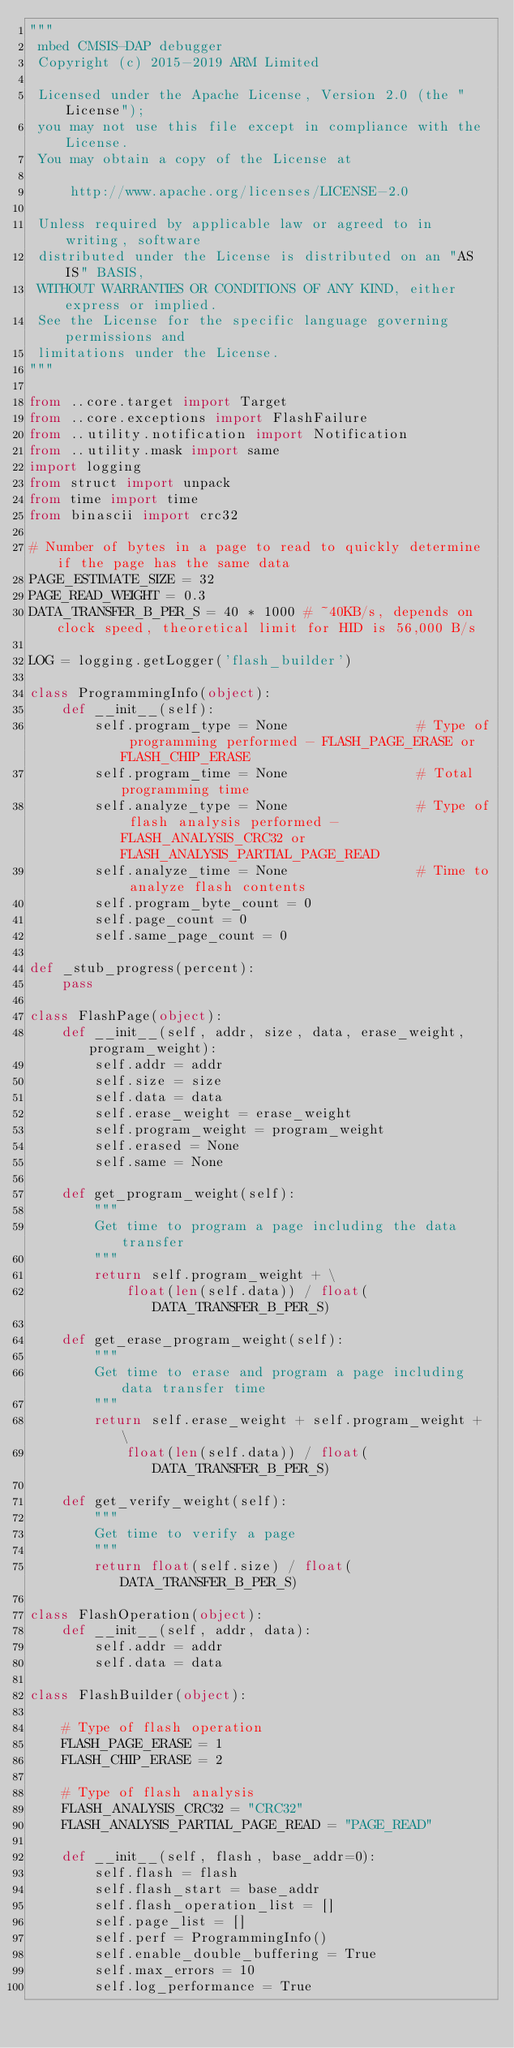<code> <loc_0><loc_0><loc_500><loc_500><_Python_>"""
 mbed CMSIS-DAP debugger
 Copyright (c) 2015-2019 ARM Limited

 Licensed under the Apache License, Version 2.0 (the "License");
 you may not use this file except in compliance with the License.
 You may obtain a copy of the License at

     http://www.apache.org/licenses/LICENSE-2.0

 Unless required by applicable law or agreed to in writing, software
 distributed under the License is distributed on an "AS IS" BASIS,
 WITHOUT WARRANTIES OR CONDITIONS OF ANY KIND, either express or implied.
 See the License for the specific language governing permissions and
 limitations under the License.
"""

from ..core.target import Target
from ..core.exceptions import FlashFailure
from ..utility.notification import Notification
from ..utility.mask import same
import logging
from struct import unpack
from time import time
from binascii import crc32

# Number of bytes in a page to read to quickly determine if the page has the same data
PAGE_ESTIMATE_SIZE = 32
PAGE_READ_WEIGHT = 0.3
DATA_TRANSFER_B_PER_S = 40 * 1000 # ~40KB/s, depends on clock speed, theoretical limit for HID is 56,000 B/s

LOG = logging.getLogger('flash_builder')

class ProgrammingInfo(object):
    def __init__(self):
        self.program_type = None                # Type of programming performed - FLASH_PAGE_ERASE or FLASH_CHIP_ERASE
        self.program_time = None                # Total programming time
        self.analyze_type = None                # Type of flash analysis performed - FLASH_ANALYSIS_CRC32 or FLASH_ANALYSIS_PARTIAL_PAGE_READ
        self.analyze_time = None                # Time to analyze flash contents
        self.program_byte_count = 0
        self.page_count = 0
        self.same_page_count = 0

def _stub_progress(percent):
    pass

class FlashPage(object):
    def __init__(self, addr, size, data, erase_weight, program_weight):
        self.addr = addr
        self.size = size
        self.data = data
        self.erase_weight = erase_weight
        self.program_weight = program_weight
        self.erased = None
        self.same = None

    def get_program_weight(self):
        """
        Get time to program a page including the data transfer
        """
        return self.program_weight + \
            float(len(self.data)) / float(DATA_TRANSFER_B_PER_S)

    def get_erase_program_weight(self):
        """
        Get time to erase and program a page including data transfer time
        """
        return self.erase_weight + self.program_weight + \
            float(len(self.data)) / float(DATA_TRANSFER_B_PER_S)

    def get_verify_weight(self):
        """
        Get time to verify a page
        """
        return float(self.size) / float(DATA_TRANSFER_B_PER_S)

class FlashOperation(object):
    def __init__(self, addr, data):
        self.addr = addr
        self.data = data

class FlashBuilder(object):

    # Type of flash operation
    FLASH_PAGE_ERASE = 1
    FLASH_CHIP_ERASE = 2

    # Type of flash analysis
    FLASH_ANALYSIS_CRC32 = "CRC32"
    FLASH_ANALYSIS_PARTIAL_PAGE_READ = "PAGE_READ"

    def __init__(self, flash, base_addr=0):
        self.flash = flash
        self.flash_start = base_addr
        self.flash_operation_list = []
        self.page_list = []
        self.perf = ProgrammingInfo()
        self.enable_double_buffering = True
        self.max_errors = 10
        self.log_performance = True</code> 